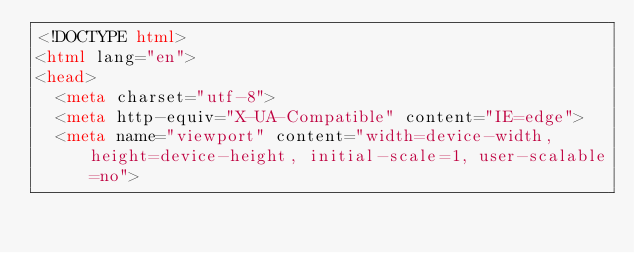<code> <loc_0><loc_0><loc_500><loc_500><_HTML_><!DOCTYPE html>
<html lang="en">
<head>
  <meta charset="utf-8">
  <meta http-equiv="X-UA-Compatible" content="IE=edge">
  <meta name="viewport" content="width=device-width, height=device-height, initial-scale=1, user-scalable=no"></code> 